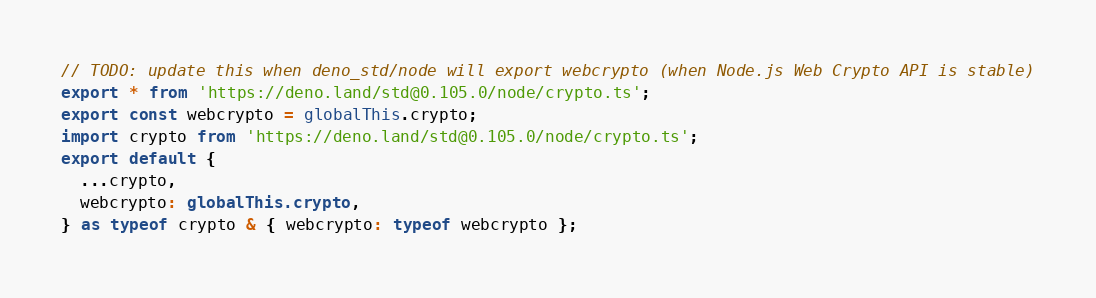<code> <loc_0><loc_0><loc_500><loc_500><_TypeScript_>// TODO: update this when deno_std/node will export webcrypto (when Node.js Web Crypto API is stable)
export * from 'https://deno.land/std@0.105.0/node/crypto.ts';
export const webcrypto = globalThis.crypto;
import crypto from 'https://deno.land/std@0.105.0/node/crypto.ts';
export default {
  ...crypto,
  webcrypto: globalThis.crypto,
} as typeof crypto & { webcrypto: typeof webcrypto };
</code> 